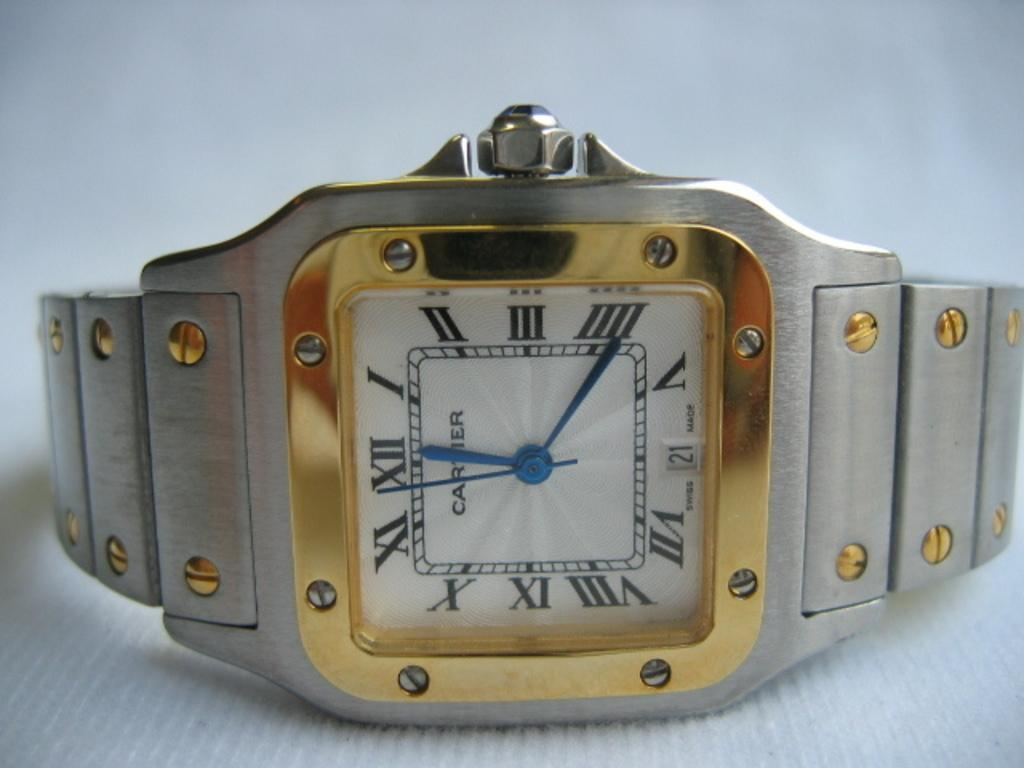<image>
Share a concise interpretation of the image provided. A silver and gold watch is made by Cartier. 